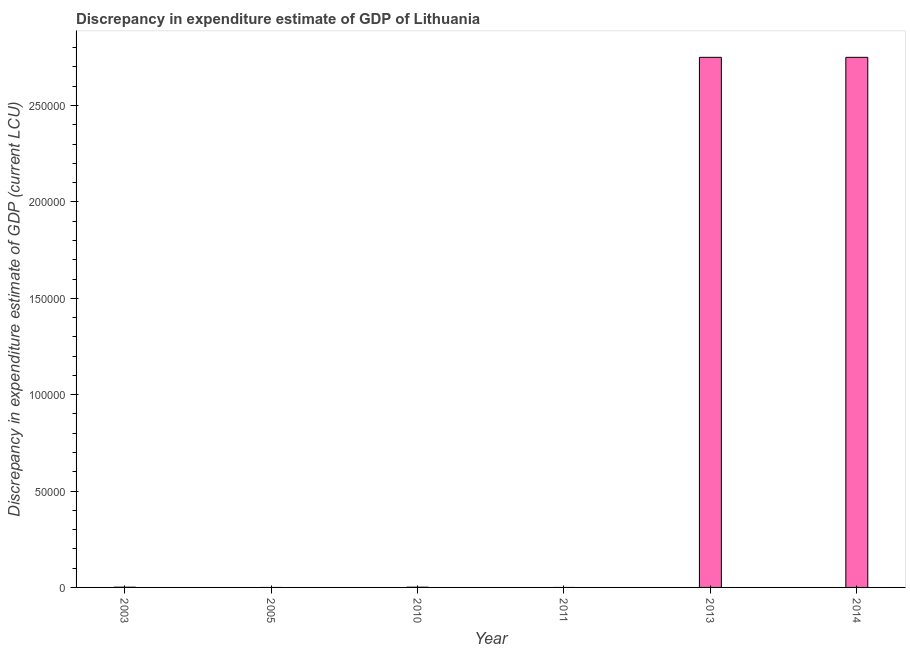Does the graph contain grids?
Offer a very short reply. No. What is the title of the graph?
Keep it short and to the point. Discrepancy in expenditure estimate of GDP of Lithuania. What is the label or title of the Y-axis?
Provide a succinct answer. Discrepancy in expenditure estimate of GDP (current LCU). What is the discrepancy in expenditure estimate of gdp in 2011?
Offer a very short reply. 0. Across all years, what is the maximum discrepancy in expenditure estimate of gdp?
Make the answer very short. 2.75e+05. Across all years, what is the minimum discrepancy in expenditure estimate of gdp?
Your answer should be very brief. 0. In which year was the discrepancy in expenditure estimate of gdp maximum?
Your answer should be very brief. 2013. What is the sum of the discrepancy in expenditure estimate of gdp?
Your answer should be compact. 5.50e+05. What is the average discrepancy in expenditure estimate of gdp per year?
Offer a very short reply. 9.17e+04. In how many years, is the discrepancy in expenditure estimate of gdp greater than 40000 LCU?
Your answer should be very brief. 2. What is the ratio of the discrepancy in expenditure estimate of gdp in 2010 to that in 2014?
Your response must be concise. 0. Is the sum of the discrepancy in expenditure estimate of gdp in 2010 and 2014 greater than the maximum discrepancy in expenditure estimate of gdp across all years?
Your answer should be compact. Yes. What is the difference between the highest and the lowest discrepancy in expenditure estimate of gdp?
Keep it short and to the point. 2.75e+05. In how many years, is the discrepancy in expenditure estimate of gdp greater than the average discrepancy in expenditure estimate of gdp taken over all years?
Your response must be concise. 2. Are all the bars in the graph horizontal?
Keep it short and to the point. No. How many years are there in the graph?
Your answer should be very brief. 6. Are the values on the major ticks of Y-axis written in scientific E-notation?
Keep it short and to the point. No. What is the Discrepancy in expenditure estimate of GDP (current LCU) in 2013?
Your response must be concise. 2.75e+05. What is the Discrepancy in expenditure estimate of GDP (current LCU) in 2014?
Provide a short and direct response. 2.75e+05. What is the difference between the Discrepancy in expenditure estimate of GDP (current LCU) in 2003 and 2013?
Ensure brevity in your answer.  -2.75e+05. What is the difference between the Discrepancy in expenditure estimate of GDP (current LCU) in 2003 and 2014?
Offer a terse response. -2.75e+05. What is the difference between the Discrepancy in expenditure estimate of GDP (current LCU) in 2010 and 2013?
Give a very brief answer. -2.75e+05. What is the difference between the Discrepancy in expenditure estimate of GDP (current LCU) in 2010 and 2014?
Provide a short and direct response. -2.75e+05. What is the difference between the Discrepancy in expenditure estimate of GDP (current LCU) in 2013 and 2014?
Give a very brief answer. 0. What is the ratio of the Discrepancy in expenditure estimate of GDP (current LCU) in 2003 to that in 2010?
Offer a terse response. 1. What is the ratio of the Discrepancy in expenditure estimate of GDP (current LCU) in 2003 to that in 2013?
Ensure brevity in your answer.  0. What is the ratio of the Discrepancy in expenditure estimate of GDP (current LCU) in 2010 to that in 2013?
Your response must be concise. 0. What is the ratio of the Discrepancy in expenditure estimate of GDP (current LCU) in 2010 to that in 2014?
Your answer should be very brief. 0. 